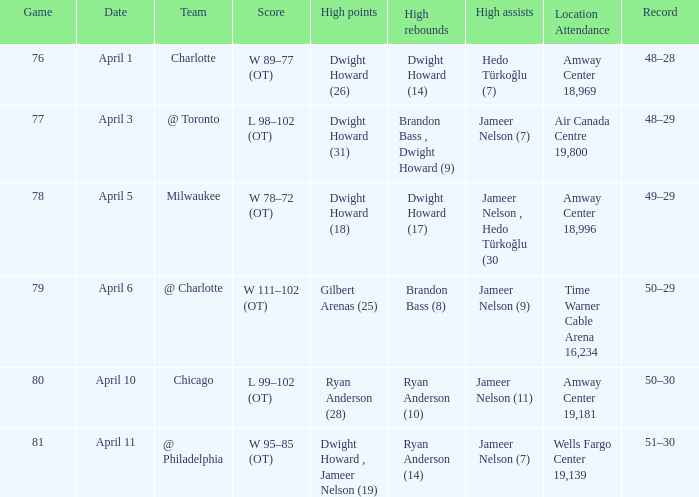Where was the game and what was the attendance on April 3?  Air Canada Centre 19,800. 